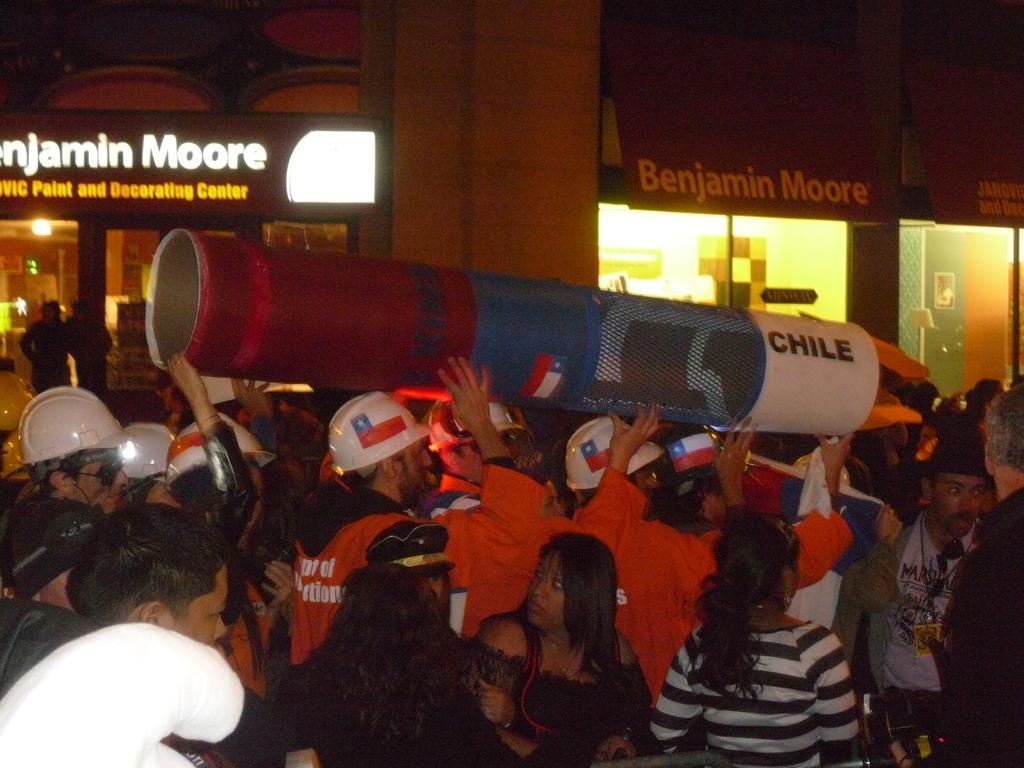Could you give a brief overview of what you see in this image? In the foreground of the picture there are people, firefighters and an object. In the background there are buildings, light, people and other objects. 